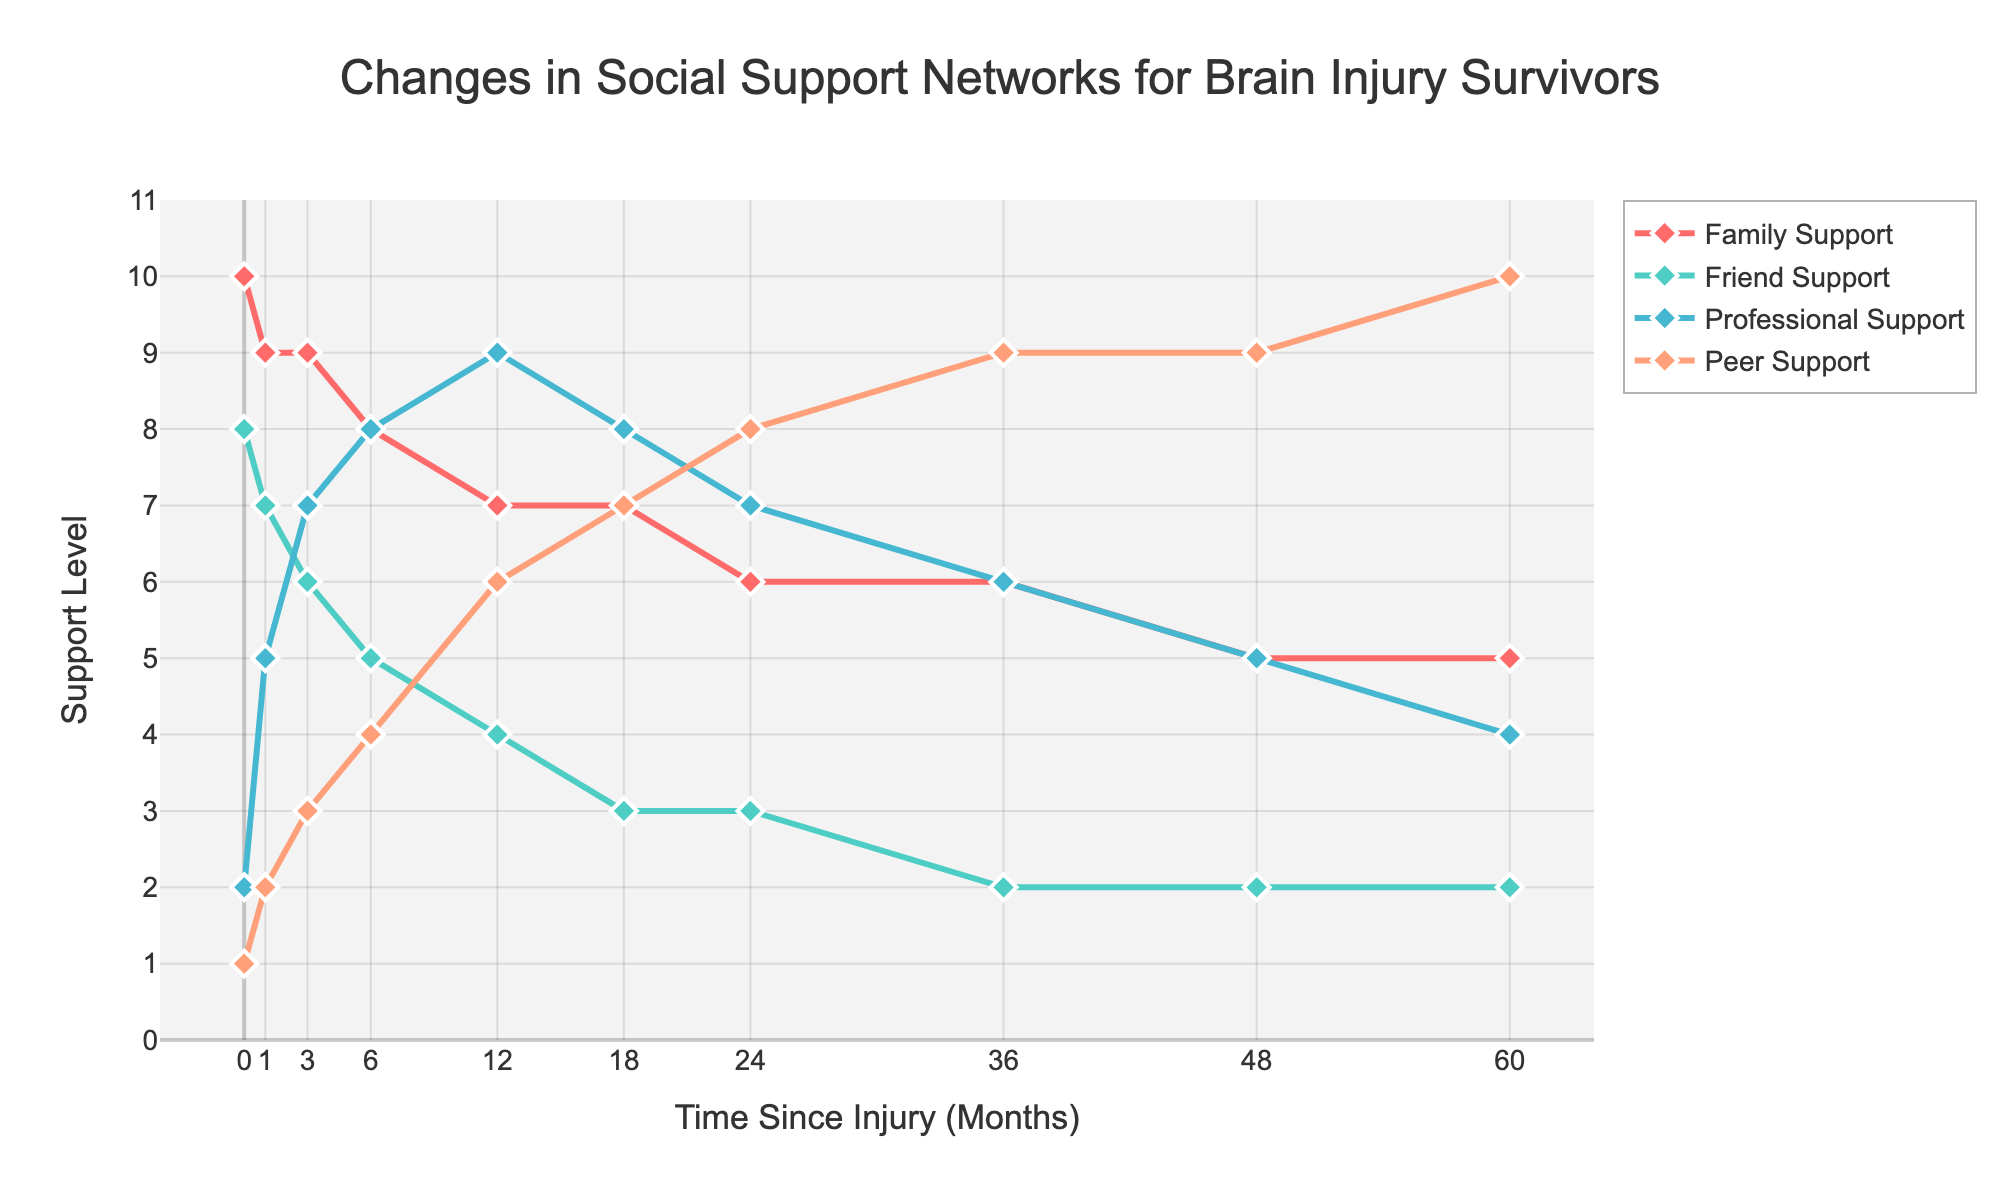What's the trend in Family Support over time? Family Support starts at a level of 10 at the beginning (0 months) and gradually declines to a level of 5 by the end of the observation period (60 months).
Answer: It declines Which type of support shows the most significant increase over time? Peer Support starts at a low level (1) at the beginning and steadily increases to the highest level (10) by the end of the observation period. By comparing the start and end points of each support type, Peer Support has the most significant increase.
Answer: Peer Support At what point does Professional Support exceed Friend Support? By looking at the intersection points in the graph, Professional Support exceeds Friend Support between 1 and 3 months and remains higher for the rest of the period.
Answer: Between 1 and 3 months What is the value of Peer Support at 12 months, and how does it compare to Family Support at the same time? The figure shows Peer Support at a level of 6 and Family Support at a level of 7 at 12 months.
Answer: Peer Support is 6 and Family Support is 7 Between which months does Friend Support drop the most significantly? Observing the graph, Friend Support declines significantly between 12 and 18 months, going from 4 to 3.
Answer: Between 12 and 18 months Which support type overtakes Friend Support first, and when does it happen? By looking at the graph, Professional Support overtakes Friend Support first around 3 months.
Answer: Professional Support at 3 months What is the average level of Family Support across the entire period? Adding all the Family Support values (10+9+9+8+7+7+6+6+5+5) and dividing by the number of values (10), we get 72/10 = 7.2.
Answer: 7.2 How does the range of Family Support compare to the range of Peer Support? The range of Family Support goes from 10 to 5 (a range of 5), while the range of Peer Support goes from 1 to 10 (a range of 9).
Answer: Family Support: 5, Peer Support: 9 Which support type remains relatively constant over the entire period? Friend Support starts at 8 and ends at 2, showing a downward trend. The remaining types vary significantly. Thus, none of the support types remain relatively constant.
Answer: None At what point in time are all types of support (Family, Friend, Professional, and Peer) levels the same, if any? According to the plot, there isn't any point where all four types of support have the same level simultaneously.
Answer: None 